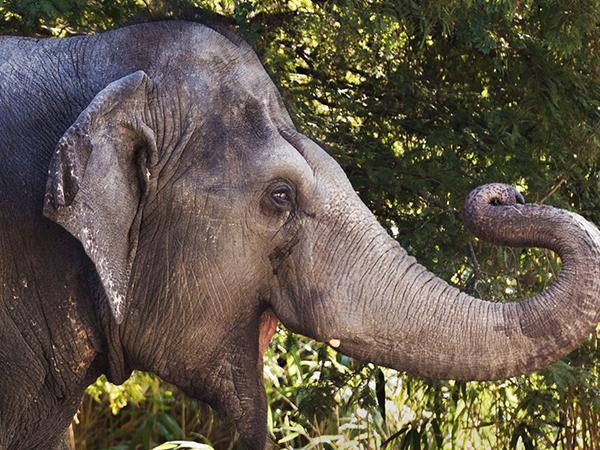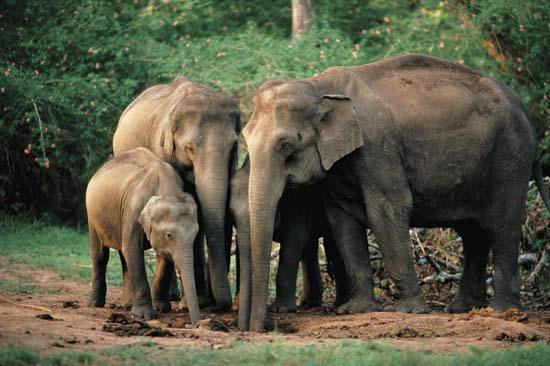The first image is the image on the left, the second image is the image on the right. Considering the images on both sides, is "An image includes exactly one elephant, which has an upraised, curled trunk." valid? Answer yes or no. Yes. The first image is the image on the left, the second image is the image on the right. Analyze the images presented: Is the assertion "A single elephant is standing in one of the images." valid? Answer yes or no. Yes. 